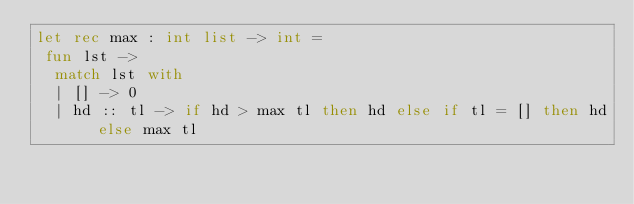<code> <loc_0><loc_0><loc_500><loc_500><_OCaml_>let rec max : int list -> int =
 fun lst ->
  match lst with
  | [] -> 0
  | hd :: tl -> if hd > max tl then hd else if tl = [] then hd else max tl
</code> 